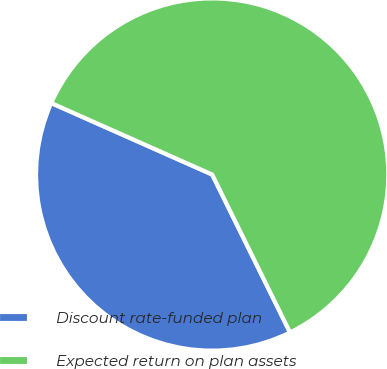Convert chart. <chart><loc_0><loc_0><loc_500><loc_500><pie_chart><fcel>Discount rate-funded plan<fcel>Expected return on plan assets<nl><fcel>38.94%<fcel>61.06%<nl></chart> 